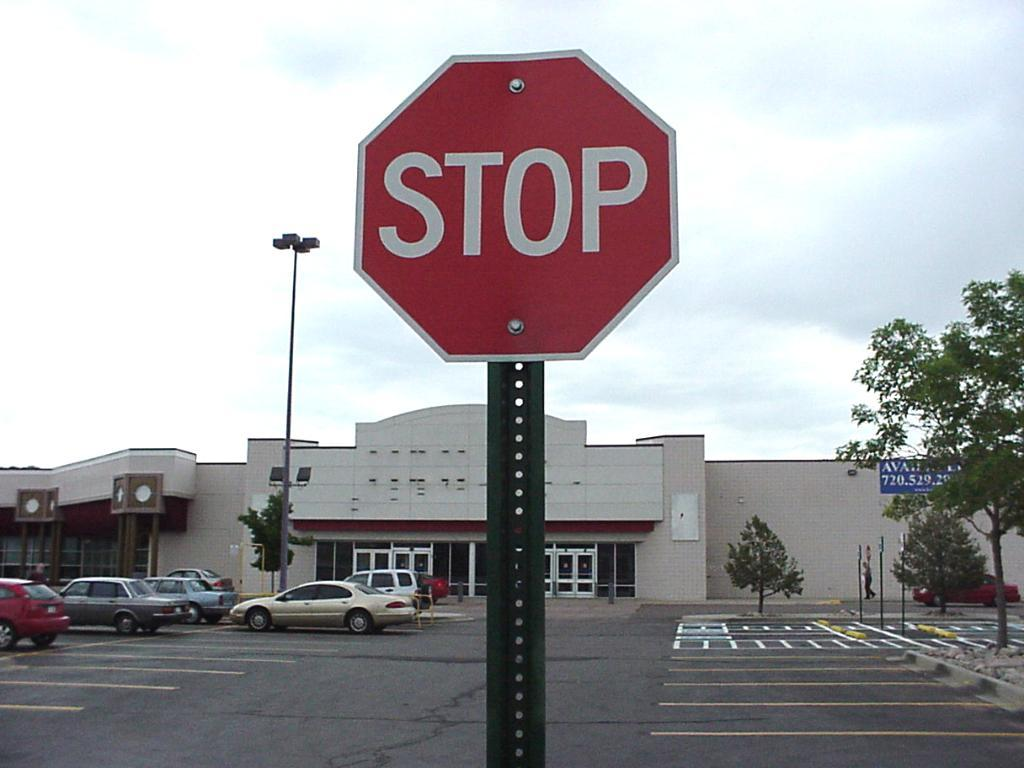<image>
Describe the image concisely. A red STOP sign is in a parking lot. 